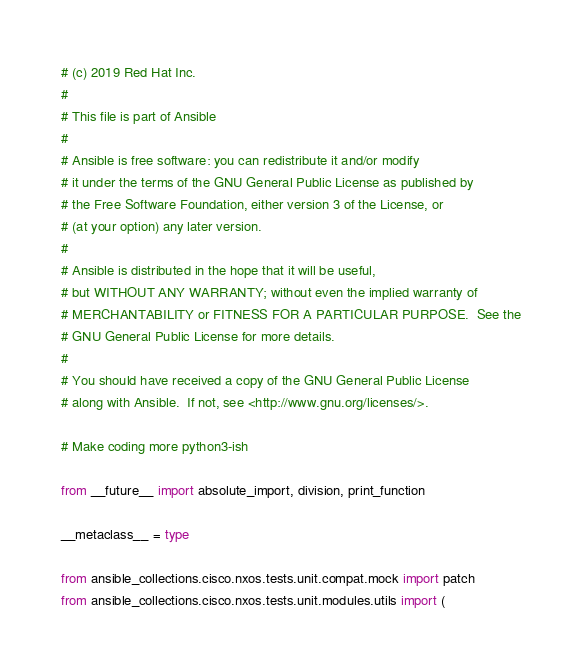<code> <loc_0><loc_0><loc_500><loc_500><_Python_># (c) 2019 Red Hat Inc.
#
# This file is part of Ansible
#
# Ansible is free software: you can redistribute it and/or modify
# it under the terms of the GNU General Public License as published by
# the Free Software Foundation, either version 3 of the License, or
# (at your option) any later version.
#
# Ansible is distributed in the hope that it will be useful,
# but WITHOUT ANY WARRANTY; without even the implied warranty of
# MERCHANTABILITY or FITNESS FOR A PARTICULAR PURPOSE.  See the
# GNU General Public License for more details.
#
# You should have received a copy of the GNU General Public License
# along with Ansible.  If not, see <http://www.gnu.org/licenses/>.

# Make coding more python3-ish

from __future__ import absolute_import, division, print_function

__metaclass__ = type

from ansible_collections.cisco.nxos.tests.unit.compat.mock import patch
from ansible_collections.cisco.nxos.tests.unit.modules.utils import (</code> 